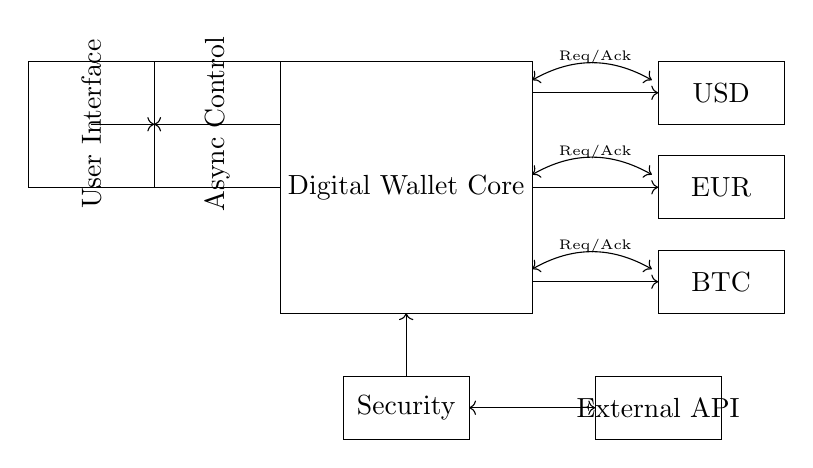What are the components present in the digital wallet circuit? The circuit features a Digital Wallet Core, three currency modules (USD, EUR, and BTC), an Asynchronous Control module, a User Interface, a Security module, and an External API module. These components are visually represented as rectangles labeled with their respective functions.
Answer: Digital Wallet Core, USD, EUR, BTC, Async Control, User Interface, Security, External API What is the purpose of the Req/Ack signals? The Req/Ack signals serve as handshake signals to manage communication between the Digital Wallet Core and the various currency modules. They ensure that requests and acknowledgments are exchanged for processing currency transactions effectively.
Answer: Handshake How many currency modules are depicted in the diagram? The circuit includes three distinct currency modules: USD, EUR, and BTC, which are represented in separate rectangles each within the circuit.
Answer: Three What is the primary function of the Security module? The Security module is responsible for safeguarding the operations of the digital wallet, ensuring the integrity and confidentiality of transactions within the circuit. Its role is crucial for protecting sensitive user information.
Answer: Safeguarding transactions Which component connects to the User Interface? The User Interface connects to the Asynchronous Control module, allowing user interactions and input to flow into the digital wallet circuit. The arrow indicates the direction of the signal flow from the User Interface towards the control system.
Answer: Asynchronous Control What type of circuit is represented in this diagram? The circuit is an asynchronous digital circuit, which operates without a global clock, utilizing handshaking signals to coordinate actions between the modules involved in processing transactions.
Answer: Asynchronous 